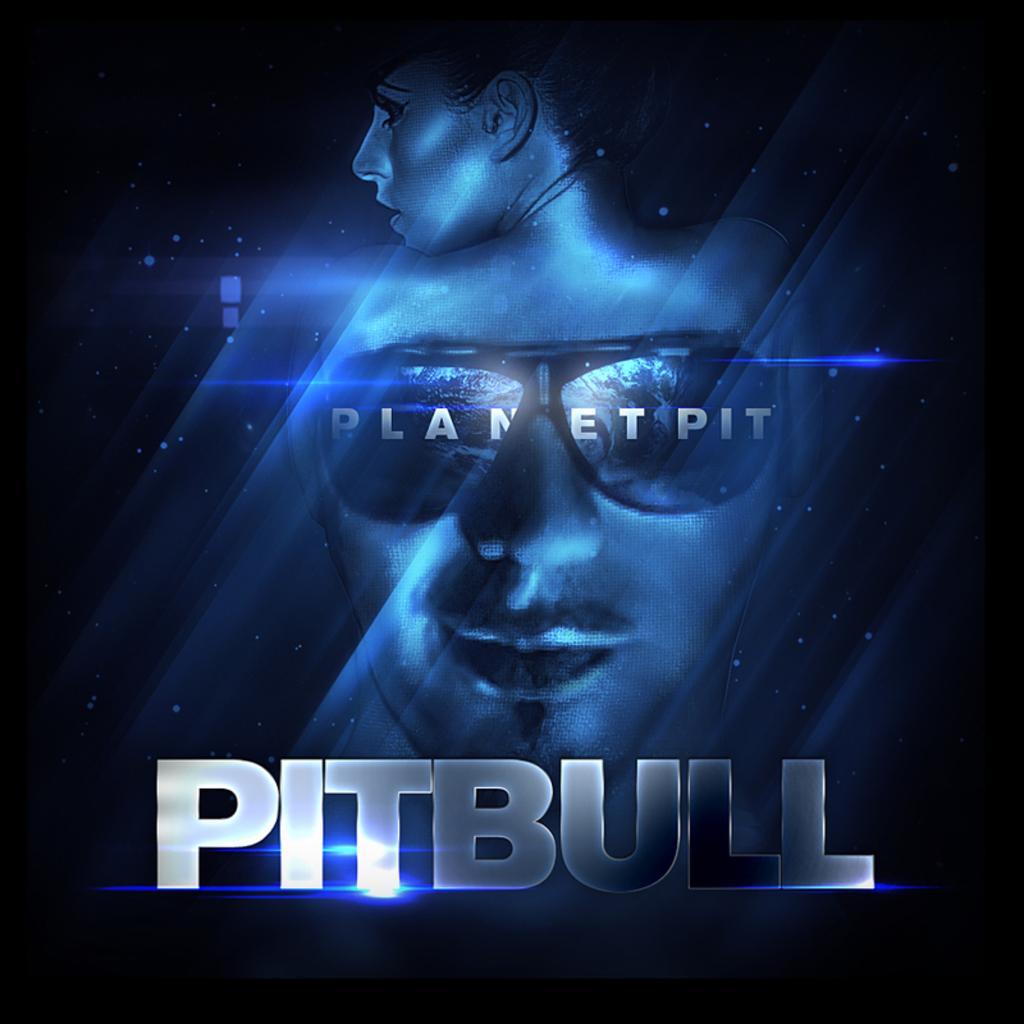Could you give a brief overview of what you see in this image? In this picture I can see a woman, glasses on man face and names on this picture. 